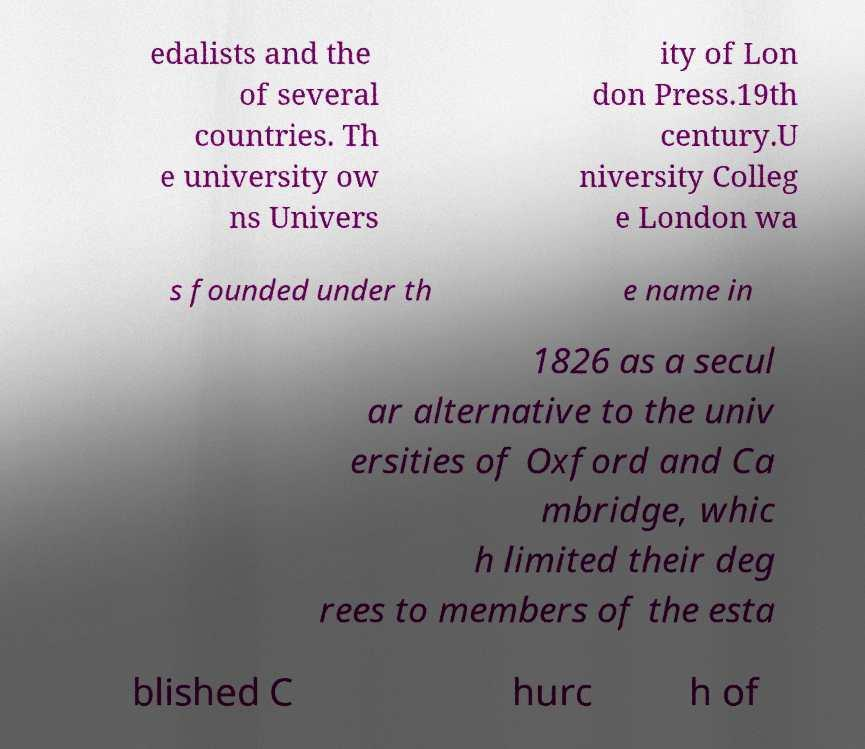Please identify and transcribe the text found in this image. edalists and the of several countries. Th e university ow ns Univers ity of Lon don Press.19th century.U niversity Colleg e London wa s founded under th e name in 1826 as a secul ar alternative to the univ ersities of Oxford and Ca mbridge, whic h limited their deg rees to members of the esta blished C hurc h of 